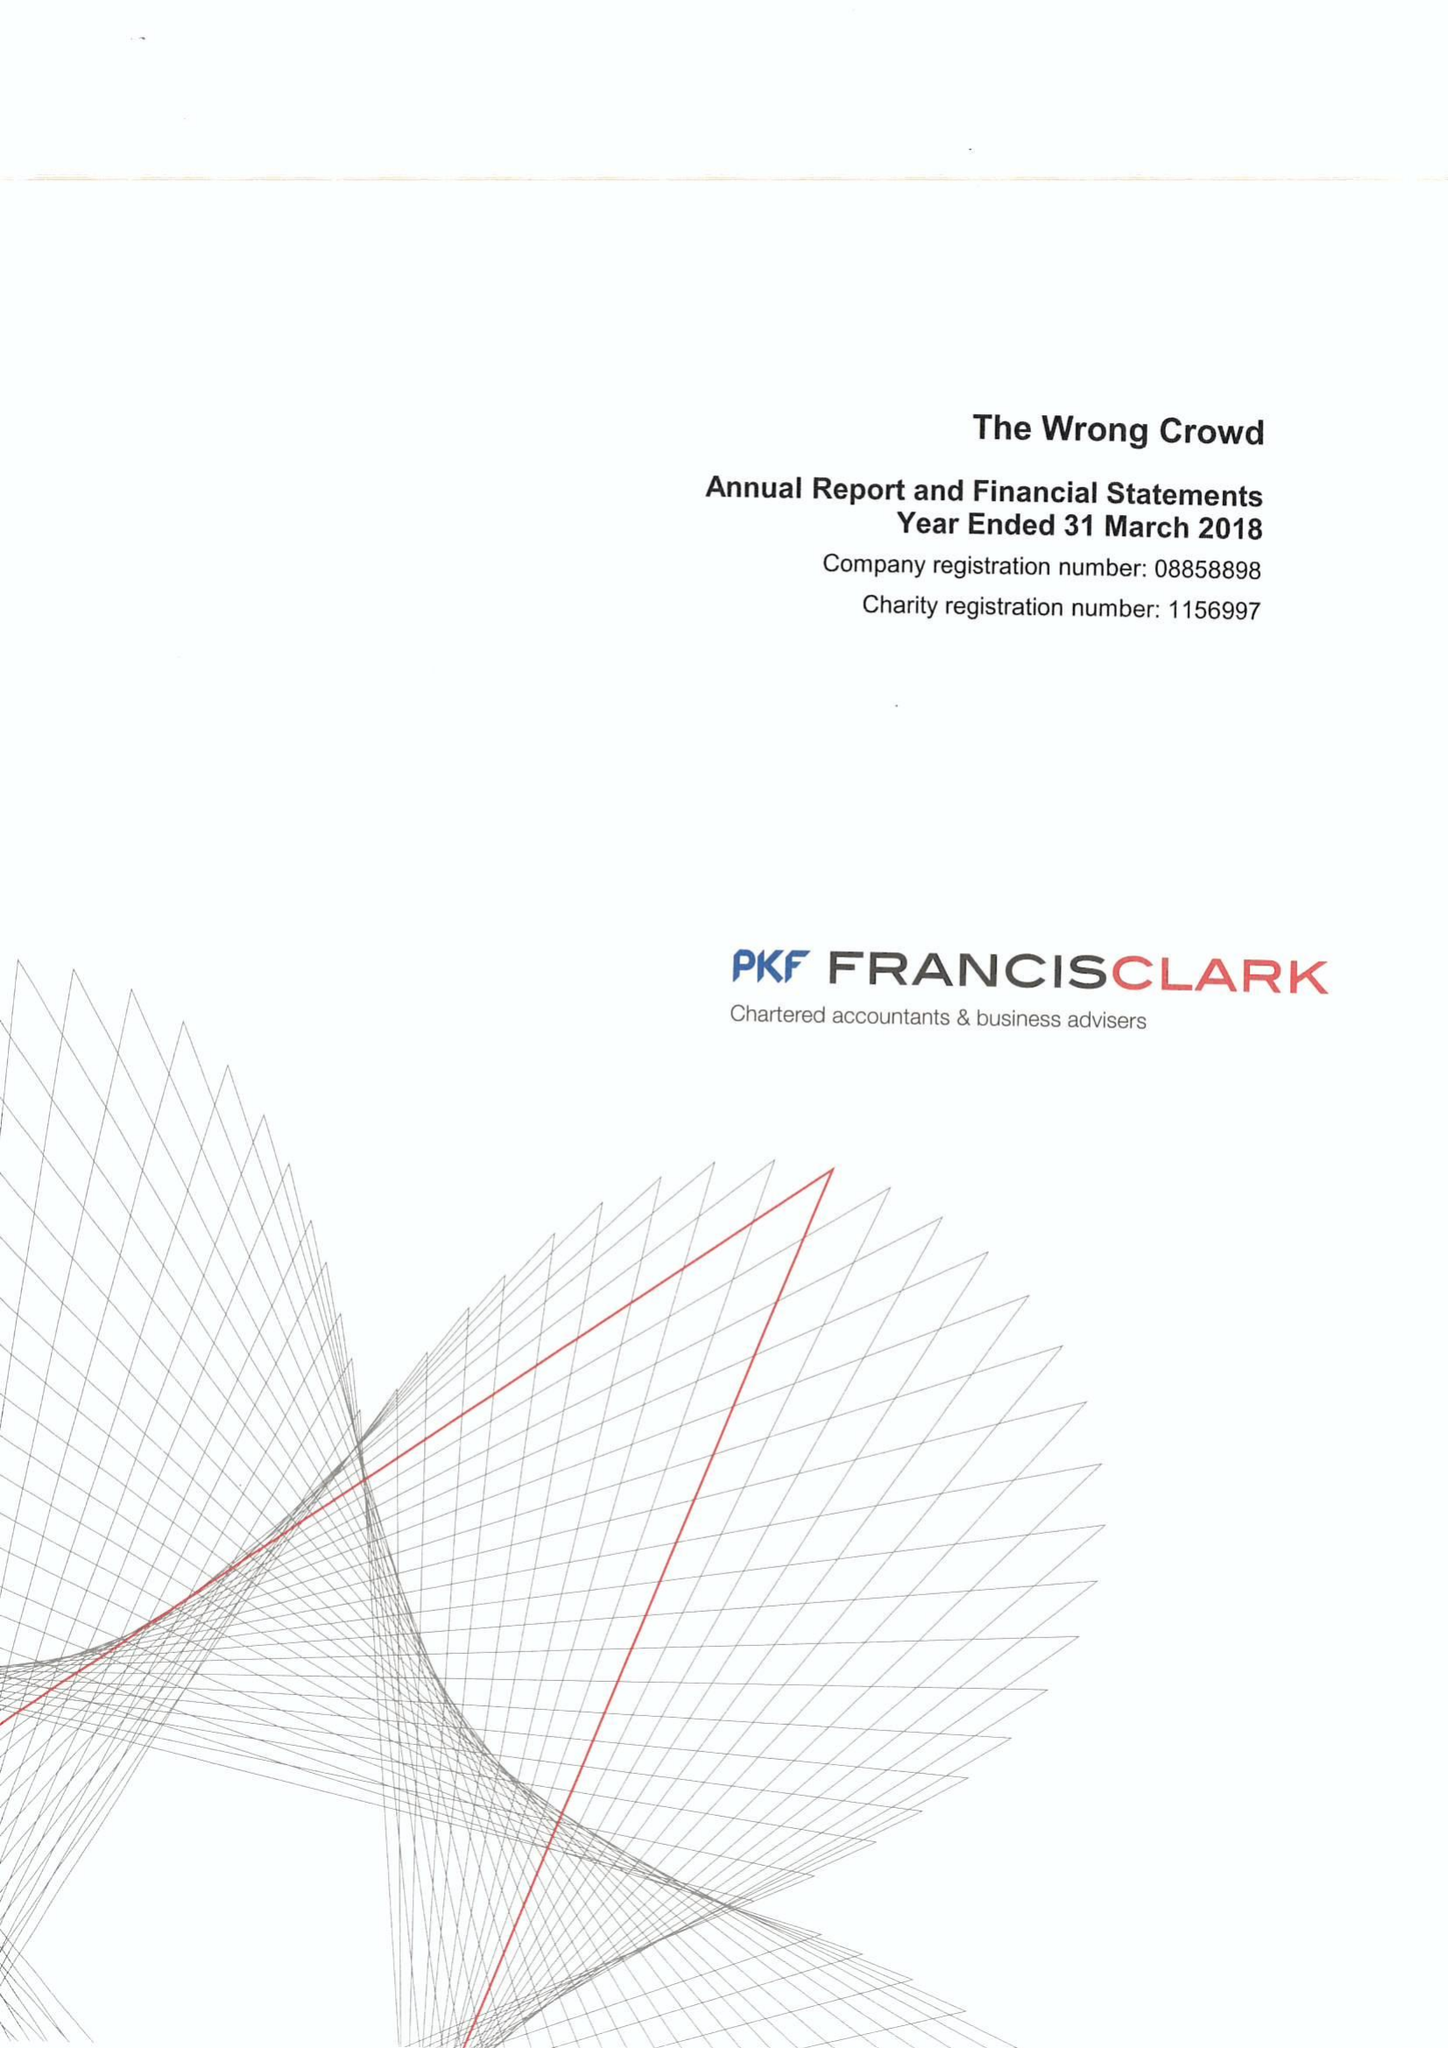What is the value for the spending_annually_in_british_pounds?
Answer the question using a single word or phrase. 147531.00 